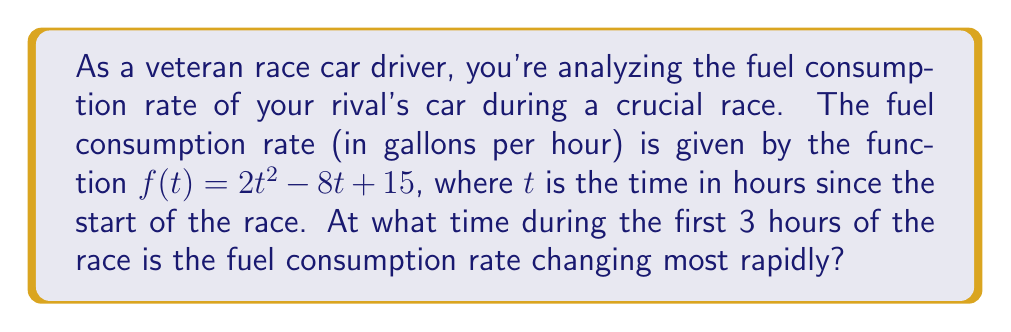Can you answer this question? To find when the fuel consumption rate is changing most rapidly, we need to find the maximum absolute value of the derivative of $f(t)$ within the given time interval.

Step 1: Find the derivative of $f(t)$.
$$f'(t) = \frac{d}{dt}(2t^2 - 8t + 15) = 4t - 8$$

Step 2: The rate of change of the fuel consumption rate is given by $f'(t)$. To find the time when it's changing most rapidly, we need to find the maximum absolute value of $f'(t)$ in the interval $[0, 3]$.

Step 3: Since $f'(t)$ is a linear function, its maximum absolute value will occur at one of the endpoints of the interval or where its derivative equals zero.

Step 4: Find where $f'(t) = 0$:
$$4t - 8 = 0$$
$$4t = 8$$
$$t = 2$$

Step 5: Evaluate $|f'(t)|$ at $t = 0$, $t = 2$, and $t = 3$:
$$|f'(0)| = |-8| = 8$$
$$|f'(2)| = |0| = 0$$
$$|f'(3)| = |4 - 8| = 4$$

Step 6: The maximum absolute value occurs at $t = 0$, which is 8.

Therefore, the fuel consumption rate is changing most rapidly at the start of the race, when $t = 0$.
Answer: $t = 0$ hours 